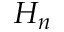<formula> <loc_0><loc_0><loc_500><loc_500>H _ { n }</formula> 